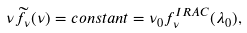<formula> <loc_0><loc_0><loc_500><loc_500>\nu \widetilde { f } _ { \nu } ( \nu ) = c o n s t a n t = \nu _ { 0 } f _ { \nu } ^ { I R A C } ( \lambda _ { 0 } ) ,</formula> 